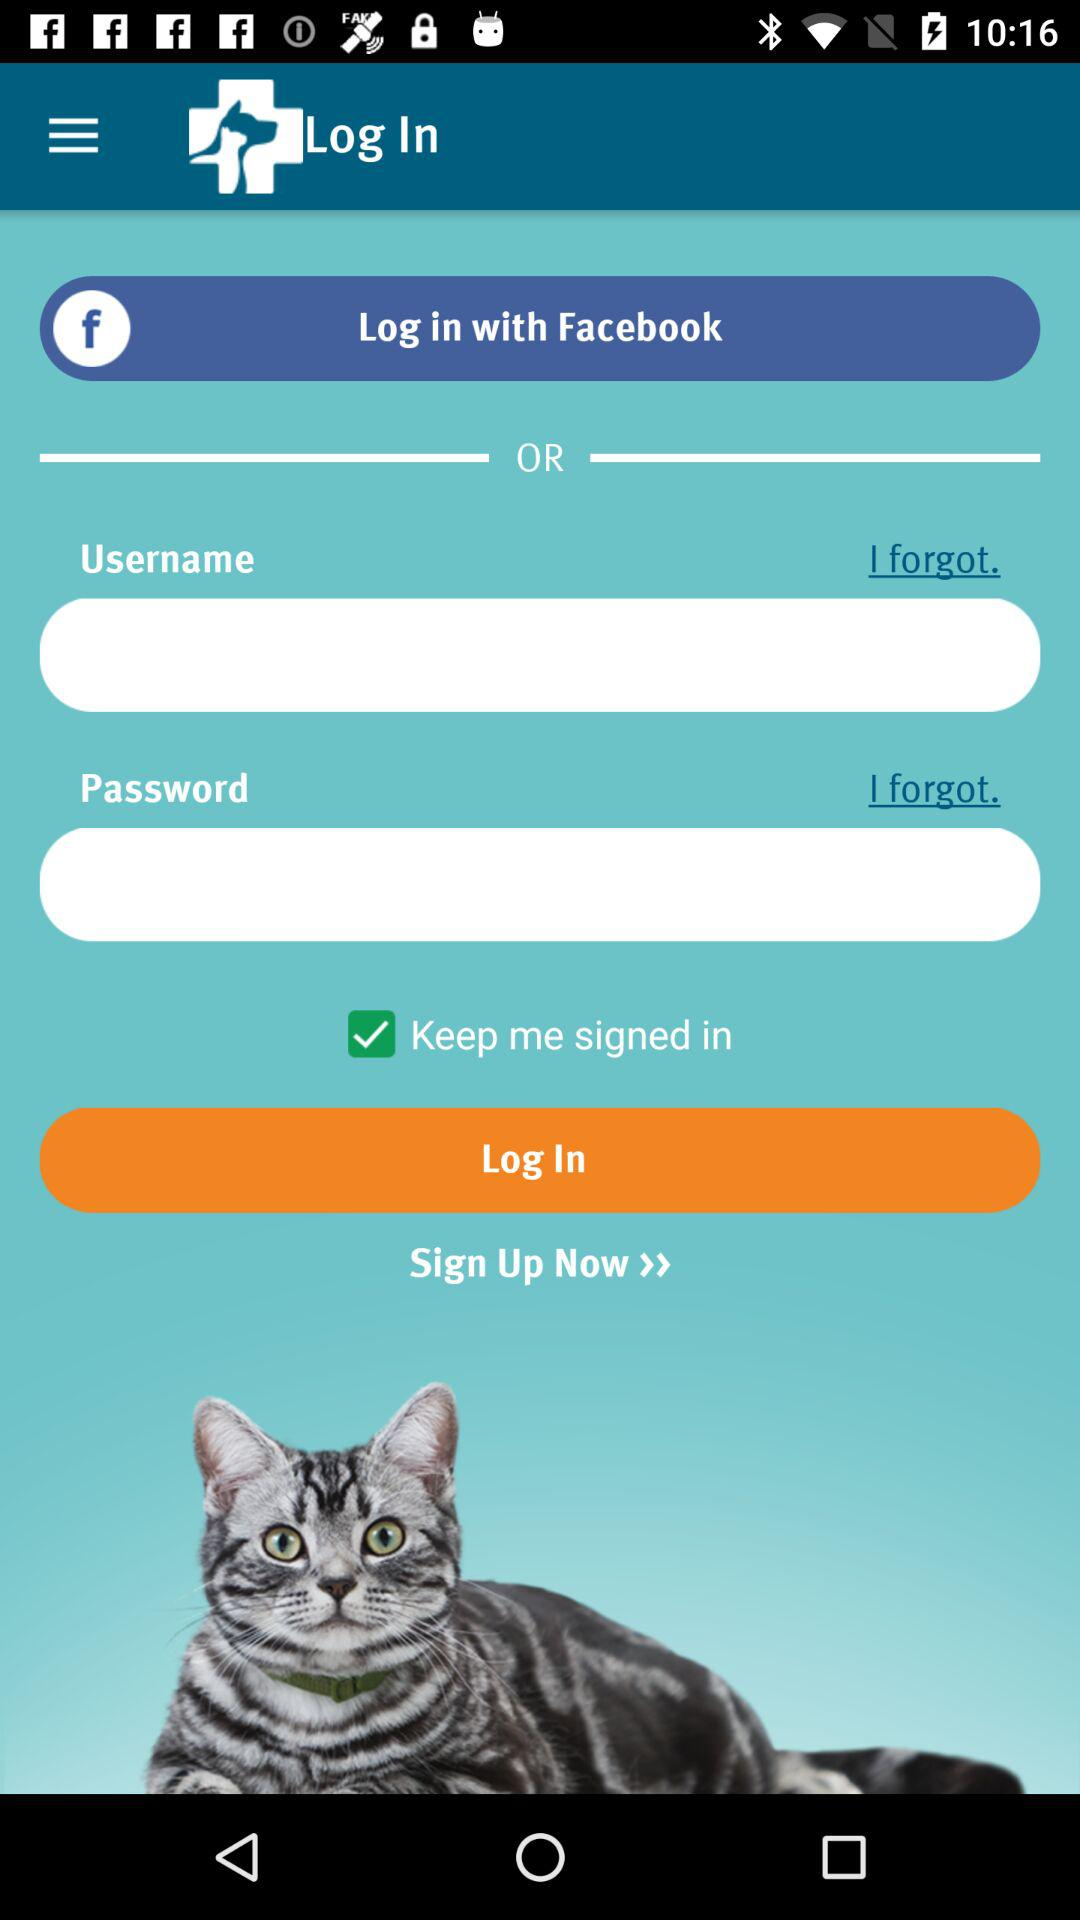What is the checked option? The checked option is "Keep me signed in". 